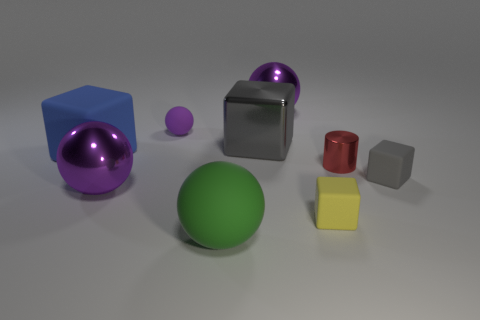How many cyan things are the same size as the red shiny thing?
Provide a short and direct response. 0. The small thing that is the same color as the large metallic block is what shape?
Offer a very short reply. Cube. What shape is the gray thing on the right side of the purple shiny ball that is behind the large matte thing behind the red object?
Provide a short and direct response. Cube. The large metal sphere in front of the shiny block is what color?
Provide a succinct answer. Purple. What number of objects are either rubber things that are in front of the blue matte thing or small objects that are on the right side of the yellow cube?
Offer a terse response. 4. How many big red matte things are the same shape as the blue object?
Keep it short and to the point. 0. What color is the rubber sphere that is the same size as the blue block?
Keep it short and to the point. Green. What is the color of the metal ball in front of the gray rubber thing that is on the right side of the sphere on the right side of the green rubber thing?
Give a very brief answer. Purple. Does the red cylinder have the same size as the gray block that is in front of the tiny red cylinder?
Give a very brief answer. Yes. How many objects are either large gray blocks or large matte balls?
Ensure brevity in your answer.  2. 